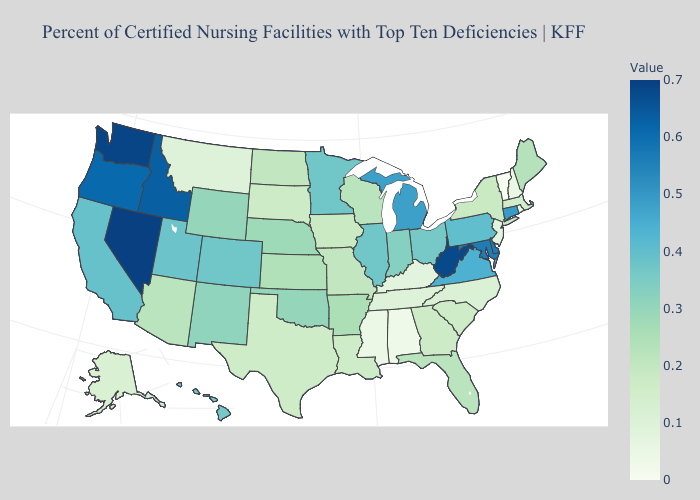Does Vermont have the lowest value in the USA?
Concise answer only. Yes. Does Illinois have the highest value in the USA?
Answer briefly. No. Does Vermont have the lowest value in the Northeast?
Give a very brief answer. Yes. Does Alaska have the lowest value in the West?
Short answer required. No. Which states hav the highest value in the West?
Quick response, please. Nevada. Does North Carolina have the lowest value in the South?
Answer briefly. No. 